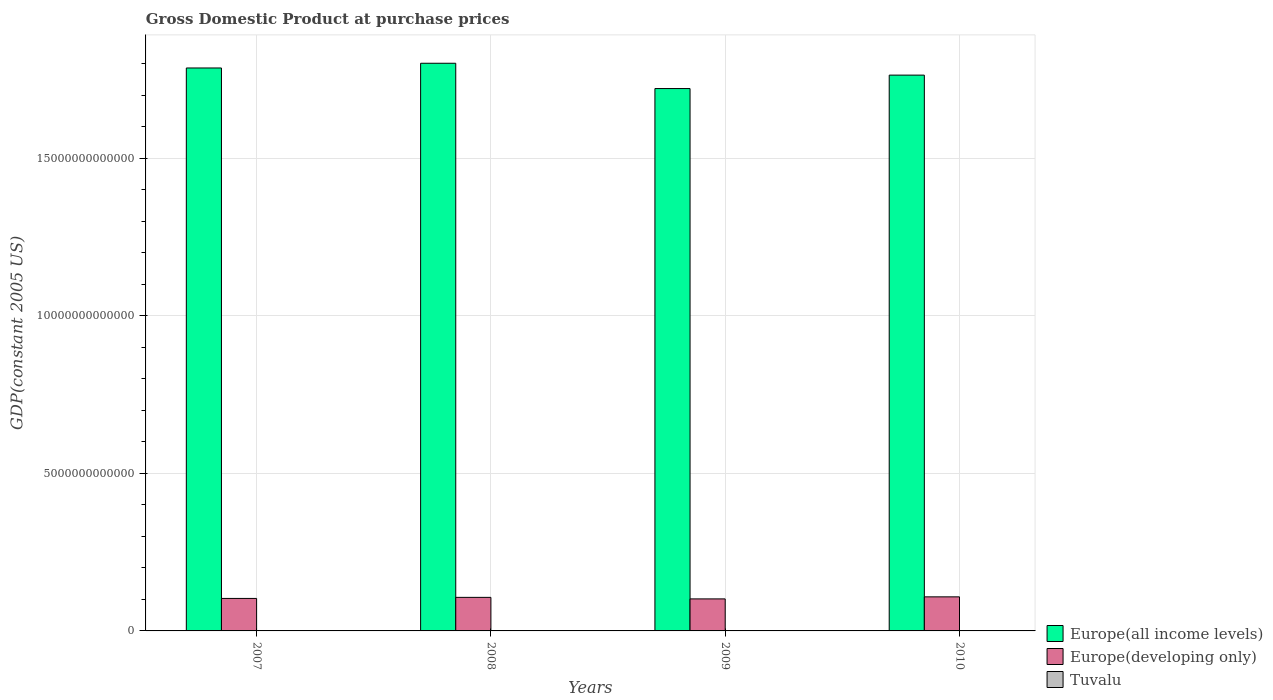How many different coloured bars are there?
Your answer should be compact. 3. How many bars are there on the 3rd tick from the right?
Your answer should be compact. 3. What is the label of the 2nd group of bars from the left?
Keep it short and to the point. 2008. What is the GDP at purchase prices in Tuvalu in 2009?
Make the answer very short. 2.45e+07. Across all years, what is the maximum GDP at purchase prices in Tuvalu?
Give a very brief answer. 2.56e+07. Across all years, what is the minimum GDP at purchase prices in Europe(all income levels)?
Your answer should be very brief. 1.72e+13. In which year was the GDP at purchase prices in Europe(all income levels) maximum?
Offer a very short reply. 2008. What is the total GDP at purchase prices in Europe(developing only) in the graph?
Provide a short and direct response. 4.19e+12. What is the difference between the GDP at purchase prices in Europe(developing only) in 2007 and that in 2009?
Your answer should be very brief. 1.47e+1. What is the difference between the GDP at purchase prices in Tuvalu in 2007 and the GDP at purchase prices in Europe(developing only) in 2009?
Your answer should be compact. -1.02e+12. What is the average GDP at purchase prices in Europe(developing only) per year?
Your answer should be very brief. 1.05e+12. In the year 2010, what is the difference between the GDP at purchase prices in Europe(developing only) and GDP at purchase prices in Europe(all income levels)?
Provide a succinct answer. -1.66e+13. In how many years, is the GDP at purchase prices in Europe(all income levels) greater than 2000000000000 US$?
Keep it short and to the point. 4. What is the ratio of the GDP at purchase prices in Europe(all income levels) in 2009 to that in 2010?
Provide a short and direct response. 0.98. Is the GDP at purchase prices in Europe(developing only) in 2009 less than that in 2010?
Provide a short and direct response. Yes. Is the difference between the GDP at purchase prices in Europe(developing only) in 2008 and 2009 greater than the difference between the GDP at purchase prices in Europe(all income levels) in 2008 and 2009?
Keep it short and to the point. No. What is the difference between the highest and the second highest GDP at purchase prices in Tuvalu?
Keep it short and to the point. 1.14e+06. What is the difference between the highest and the lowest GDP at purchase prices in Tuvalu?
Ensure brevity in your answer.  1.89e+06. What does the 3rd bar from the left in 2008 represents?
Provide a succinct answer. Tuvalu. What does the 1st bar from the right in 2010 represents?
Your response must be concise. Tuvalu. Is it the case that in every year, the sum of the GDP at purchase prices in Europe(all income levels) and GDP at purchase prices in Europe(developing only) is greater than the GDP at purchase prices in Tuvalu?
Provide a short and direct response. Yes. How many bars are there?
Give a very brief answer. 12. What is the difference between two consecutive major ticks on the Y-axis?
Keep it short and to the point. 5.00e+12. Where does the legend appear in the graph?
Keep it short and to the point. Bottom right. How many legend labels are there?
Give a very brief answer. 3. What is the title of the graph?
Offer a terse response. Gross Domestic Product at purchase prices. What is the label or title of the X-axis?
Offer a very short reply. Years. What is the label or title of the Y-axis?
Make the answer very short. GDP(constant 2005 US). What is the GDP(constant 2005 US) of Europe(all income levels) in 2007?
Keep it short and to the point. 1.79e+13. What is the GDP(constant 2005 US) in Europe(developing only) in 2007?
Provide a short and direct response. 1.03e+12. What is the GDP(constant 2005 US) of Tuvalu in 2007?
Your response must be concise. 2.37e+07. What is the GDP(constant 2005 US) of Europe(all income levels) in 2008?
Offer a very short reply. 1.80e+13. What is the GDP(constant 2005 US) in Europe(developing only) in 2008?
Keep it short and to the point. 1.06e+12. What is the GDP(constant 2005 US) in Tuvalu in 2008?
Provide a short and direct response. 2.56e+07. What is the GDP(constant 2005 US) in Europe(all income levels) in 2009?
Offer a terse response. 1.72e+13. What is the GDP(constant 2005 US) in Europe(developing only) in 2009?
Your response must be concise. 1.02e+12. What is the GDP(constant 2005 US) of Tuvalu in 2009?
Offer a very short reply. 2.45e+07. What is the GDP(constant 2005 US) of Europe(all income levels) in 2010?
Keep it short and to the point. 1.76e+13. What is the GDP(constant 2005 US) of Europe(developing only) in 2010?
Your answer should be compact. 1.08e+12. What is the GDP(constant 2005 US) in Tuvalu in 2010?
Keep it short and to the point. 2.38e+07. Across all years, what is the maximum GDP(constant 2005 US) of Europe(all income levels)?
Keep it short and to the point. 1.80e+13. Across all years, what is the maximum GDP(constant 2005 US) in Europe(developing only)?
Provide a succinct answer. 1.08e+12. Across all years, what is the maximum GDP(constant 2005 US) in Tuvalu?
Your response must be concise. 2.56e+07. Across all years, what is the minimum GDP(constant 2005 US) of Europe(all income levels)?
Offer a very short reply. 1.72e+13. Across all years, what is the minimum GDP(constant 2005 US) in Europe(developing only)?
Your answer should be very brief. 1.02e+12. Across all years, what is the minimum GDP(constant 2005 US) in Tuvalu?
Provide a short and direct response. 2.37e+07. What is the total GDP(constant 2005 US) of Europe(all income levels) in the graph?
Your answer should be compact. 7.07e+13. What is the total GDP(constant 2005 US) in Europe(developing only) in the graph?
Give a very brief answer. 4.19e+12. What is the total GDP(constant 2005 US) in Tuvalu in the graph?
Ensure brevity in your answer.  9.76e+07. What is the difference between the GDP(constant 2005 US) in Europe(all income levels) in 2007 and that in 2008?
Give a very brief answer. -1.50e+11. What is the difference between the GDP(constant 2005 US) of Europe(developing only) in 2007 and that in 2008?
Your response must be concise. -3.39e+1. What is the difference between the GDP(constant 2005 US) of Tuvalu in 2007 and that in 2008?
Offer a terse response. -1.89e+06. What is the difference between the GDP(constant 2005 US) in Europe(all income levels) in 2007 and that in 2009?
Make the answer very short. 6.53e+11. What is the difference between the GDP(constant 2005 US) of Europe(developing only) in 2007 and that in 2009?
Your answer should be compact. 1.47e+1. What is the difference between the GDP(constant 2005 US) of Tuvalu in 2007 and that in 2009?
Provide a short and direct response. -7.58e+05. What is the difference between the GDP(constant 2005 US) in Europe(all income levels) in 2007 and that in 2010?
Your answer should be very brief. 2.26e+11. What is the difference between the GDP(constant 2005 US) of Europe(developing only) in 2007 and that in 2010?
Give a very brief answer. -5.01e+1. What is the difference between the GDP(constant 2005 US) of Tuvalu in 2007 and that in 2010?
Offer a very short reply. -9.01e+04. What is the difference between the GDP(constant 2005 US) of Europe(all income levels) in 2008 and that in 2009?
Offer a very short reply. 8.03e+11. What is the difference between the GDP(constant 2005 US) in Europe(developing only) in 2008 and that in 2009?
Ensure brevity in your answer.  4.86e+1. What is the difference between the GDP(constant 2005 US) in Tuvalu in 2008 and that in 2009?
Your response must be concise. 1.14e+06. What is the difference between the GDP(constant 2005 US) of Europe(all income levels) in 2008 and that in 2010?
Offer a very short reply. 3.76e+11. What is the difference between the GDP(constant 2005 US) of Europe(developing only) in 2008 and that in 2010?
Your answer should be compact. -1.62e+1. What is the difference between the GDP(constant 2005 US) in Tuvalu in 2008 and that in 2010?
Provide a succinct answer. 1.80e+06. What is the difference between the GDP(constant 2005 US) in Europe(all income levels) in 2009 and that in 2010?
Offer a very short reply. -4.27e+11. What is the difference between the GDP(constant 2005 US) of Europe(developing only) in 2009 and that in 2010?
Make the answer very short. -6.47e+1. What is the difference between the GDP(constant 2005 US) in Tuvalu in 2009 and that in 2010?
Keep it short and to the point. 6.68e+05. What is the difference between the GDP(constant 2005 US) of Europe(all income levels) in 2007 and the GDP(constant 2005 US) of Europe(developing only) in 2008?
Your answer should be compact. 1.68e+13. What is the difference between the GDP(constant 2005 US) of Europe(all income levels) in 2007 and the GDP(constant 2005 US) of Tuvalu in 2008?
Provide a short and direct response. 1.79e+13. What is the difference between the GDP(constant 2005 US) of Europe(developing only) in 2007 and the GDP(constant 2005 US) of Tuvalu in 2008?
Keep it short and to the point. 1.03e+12. What is the difference between the GDP(constant 2005 US) of Europe(all income levels) in 2007 and the GDP(constant 2005 US) of Europe(developing only) in 2009?
Offer a very short reply. 1.68e+13. What is the difference between the GDP(constant 2005 US) of Europe(all income levels) in 2007 and the GDP(constant 2005 US) of Tuvalu in 2009?
Your answer should be compact. 1.79e+13. What is the difference between the GDP(constant 2005 US) of Europe(developing only) in 2007 and the GDP(constant 2005 US) of Tuvalu in 2009?
Offer a terse response. 1.03e+12. What is the difference between the GDP(constant 2005 US) in Europe(all income levels) in 2007 and the GDP(constant 2005 US) in Europe(developing only) in 2010?
Offer a very short reply. 1.68e+13. What is the difference between the GDP(constant 2005 US) in Europe(all income levels) in 2007 and the GDP(constant 2005 US) in Tuvalu in 2010?
Keep it short and to the point. 1.79e+13. What is the difference between the GDP(constant 2005 US) in Europe(developing only) in 2007 and the GDP(constant 2005 US) in Tuvalu in 2010?
Keep it short and to the point. 1.03e+12. What is the difference between the GDP(constant 2005 US) of Europe(all income levels) in 2008 and the GDP(constant 2005 US) of Europe(developing only) in 2009?
Make the answer very short. 1.70e+13. What is the difference between the GDP(constant 2005 US) of Europe(all income levels) in 2008 and the GDP(constant 2005 US) of Tuvalu in 2009?
Give a very brief answer. 1.80e+13. What is the difference between the GDP(constant 2005 US) in Europe(developing only) in 2008 and the GDP(constant 2005 US) in Tuvalu in 2009?
Give a very brief answer. 1.06e+12. What is the difference between the GDP(constant 2005 US) in Europe(all income levels) in 2008 and the GDP(constant 2005 US) in Europe(developing only) in 2010?
Your answer should be very brief. 1.69e+13. What is the difference between the GDP(constant 2005 US) in Europe(all income levels) in 2008 and the GDP(constant 2005 US) in Tuvalu in 2010?
Make the answer very short. 1.80e+13. What is the difference between the GDP(constant 2005 US) in Europe(developing only) in 2008 and the GDP(constant 2005 US) in Tuvalu in 2010?
Provide a succinct answer. 1.06e+12. What is the difference between the GDP(constant 2005 US) of Europe(all income levels) in 2009 and the GDP(constant 2005 US) of Europe(developing only) in 2010?
Offer a very short reply. 1.61e+13. What is the difference between the GDP(constant 2005 US) of Europe(all income levels) in 2009 and the GDP(constant 2005 US) of Tuvalu in 2010?
Give a very brief answer. 1.72e+13. What is the difference between the GDP(constant 2005 US) of Europe(developing only) in 2009 and the GDP(constant 2005 US) of Tuvalu in 2010?
Keep it short and to the point. 1.02e+12. What is the average GDP(constant 2005 US) in Europe(all income levels) per year?
Give a very brief answer. 1.77e+13. What is the average GDP(constant 2005 US) of Europe(developing only) per year?
Ensure brevity in your answer.  1.05e+12. What is the average GDP(constant 2005 US) in Tuvalu per year?
Provide a short and direct response. 2.44e+07. In the year 2007, what is the difference between the GDP(constant 2005 US) in Europe(all income levels) and GDP(constant 2005 US) in Europe(developing only)?
Your answer should be compact. 1.68e+13. In the year 2007, what is the difference between the GDP(constant 2005 US) of Europe(all income levels) and GDP(constant 2005 US) of Tuvalu?
Keep it short and to the point. 1.79e+13. In the year 2007, what is the difference between the GDP(constant 2005 US) in Europe(developing only) and GDP(constant 2005 US) in Tuvalu?
Ensure brevity in your answer.  1.03e+12. In the year 2008, what is the difference between the GDP(constant 2005 US) of Europe(all income levels) and GDP(constant 2005 US) of Europe(developing only)?
Offer a terse response. 1.69e+13. In the year 2008, what is the difference between the GDP(constant 2005 US) in Europe(all income levels) and GDP(constant 2005 US) in Tuvalu?
Provide a short and direct response. 1.80e+13. In the year 2008, what is the difference between the GDP(constant 2005 US) in Europe(developing only) and GDP(constant 2005 US) in Tuvalu?
Keep it short and to the point. 1.06e+12. In the year 2009, what is the difference between the GDP(constant 2005 US) of Europe(all income levels) and GDP(constant 2005 US) of Europe(developing only)?
Give a very brief answer. 1.62e+13. In the year 2009, what is the difference between the GDP(constant 2005 US) of Europe(all income levels) and GDP(constant 2005 US) of Tuvalu?
Your answer should be very brief. 1.72e+13. In the year 2009, what is the difference between the GDP(constant 2005 US) of Europe(developing only) and GDP(constant 2005 US) of Tuvalu?
Offer a terse response. 1.02e+12. In the year 2010, what is the difference between the GDP(constant 2005 US) of Europe(all income levels) and GDP(constant 2005 US) of Europe(developing only)?
Make the answer very short. 1.66e+13. In the year 2010, what is the difference between the GDP(constant 2005 US) of Europe(all income levels) and GDP(constant 2005 US) of Tuvalu?
Your response must be concise. 1.76e+13. In the year 2010, what is the difference between the GDP(constant 2005 US) in Europe(developing only) and GDP(constant 2005 US) in Tuvalu?
Offer a very short reply. 1.08e+12. What is the ratio of the GDP(constant 2005 US) of Europe(all income levels) in 2007 to that in 2008?
Your answer should be very brief. 0.99. What is the ratio of the GDP(constant 2005 US) in Europe(developing only) in 2007 to that in 2008?
Your answer should be very brief. 0.97. What is the ratio of the GDP(constant 2005 US) of Tuvalu in 2007 to that in 2008?
Offer a very short reply. 0.93. What is the ratio of the GDP(constant 2005 US) of Europe(all income levels) in 2007 to that in 2009?
Give a very brief answer. 1.04. What is the ratio of the GDP(constant 2005 US) of Europe(developing only) in 2007 to that in 2009?
Offer a very short reply. 1.01. What is the ratio of the GDP(constant 2005 US) in Europe(all income levels) in 2007 to that in 2010?
Offer a very short reply. 1.01. What is the ratio of the GDP(constant 2005 US) of Europe(developing only) in 2007 to that in 2010?
Provide a short and direct response. 0.95. What is the ratio of the GDP(constant 2005 US) in Tuvalu in 2007 to that in 2010?
Your response must be concise. 1. What is the ratio of the GDP(constant 2005 US) in Europe(all income levels) in 2008 to that in 2009?
Your response must be concise. 1.05. What is the ratio of the GDP(constant 2005 US) of Europe(developing only) in 2008 to that in 2009?
Provide a short and direct response. 1.05. What is the ratio of the GDP(constant 2005 US) of Tuvalu in 2008 to that in 2009?
Make the answer very short. 1.05. What is the ratio of the GDP(constant 2005 US) of Europe(all income levels) in 2008 to that in 2010?
Make the answer very short. 1.02. What is the ratio of the GDP(constant 2005 US) in Tuvalu in 2008 to that in 2010?
Provide a succinct answer. 1.08. What is the ratio of the GDP(constant 2005 US) in Europe(all income levels) in 2009 to that in 2010?
Ensure brevity in your answer.  0.98. What is the ratio of the GDP(constant 2005 US) in Europe(developing only) in 2009 to that in 2010?
Make the answer very short. 0.94. What is the ratio of the GDP(constant 2005 US) in Tuvalu in 2009 to that in 2010?
Your answer should be compact. 1.03. What is the difference between the highest and the second highest GDP(constant 2005 US) in Europe(all income levels)?
Keep it short and to the point. 1.50e+11. What is the difference between the highest and the second highest GDP(constant 2005 US) of Europe(developing only)?
Offer a terse response. 1.62e+1. What is the difference between the highest and the second highest GDP(constant 2005 US) in Tuvalu?
Your answer should be very brief. 1.14e+06. What is the difference between the highest and the lowest GDP(constant 2005 US) in Europe(all income levels)?
Offer a very short reply. 8.03e+11. What is the difference between the highest and the lowest GDP(constant 2005 US) of Europe(developing only)?
Your answer should be compact. 6.47e+1. What is the difference between the highest and the lowest GDP(constant 2005 US) of Tuvalu?
Offer a terse response. 1.89e+06. 